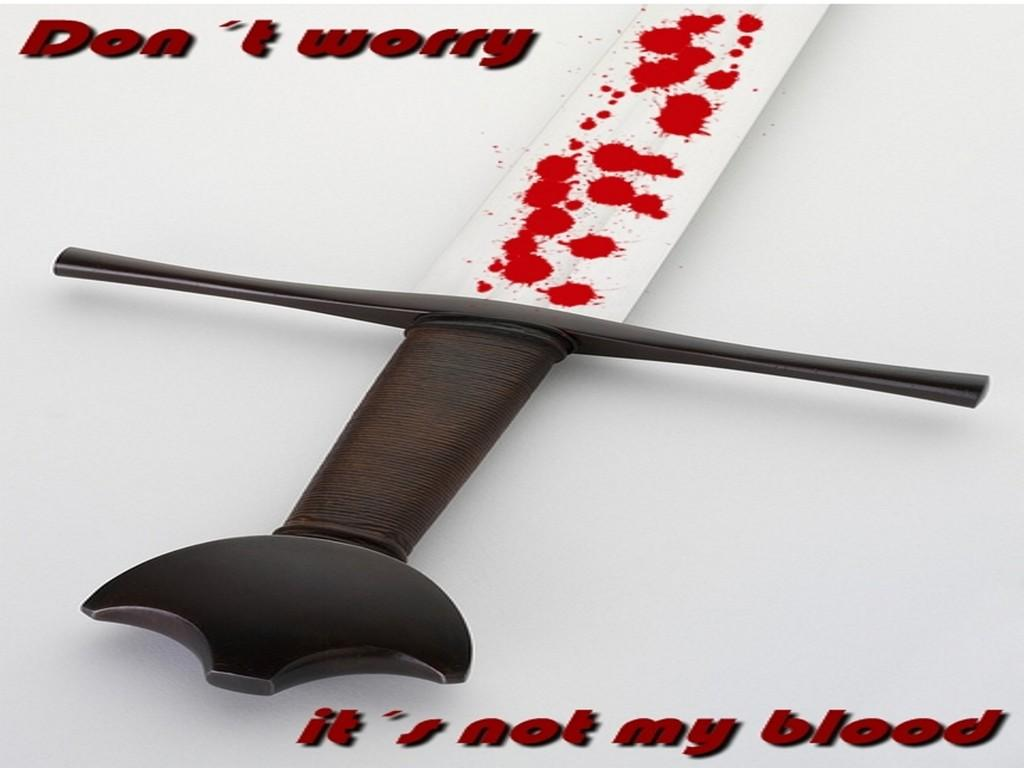What object can be seen in the top left of the image? There is a sword in the top left of the image. What else is present in the top left of the image besides the sword? There is text in the top left of the image. Where can more text be found in the image? There is text in the bottom right of the image. How many pigs are depicted in the image? There are no pigs present in the image. What type of cabbage is being used to create the text in the image? There is no cabbage present in the image; the text is not made of any vegetables. 